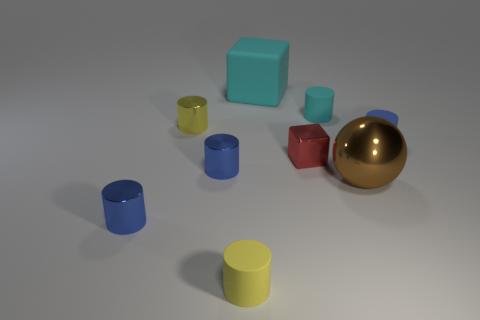Subtract all blue cylinders. How many were subtracted if there are1blue cylinders left? 2 Subtract all small yellow cylinders. How many cylinders are left? 4 Subtract all cyan cylinders. How many cylinders are left? 5 Subtract 3 cylinders. How many cylinders are left? 3 Subtract all purple balls. How many blue cylinders are left? 3 Add 9 small red metallic blocks. How many small red metallic blocks are left? 10 Add 4 tiny blue objects. How many tiny blue objects exist? 7 Subtract 0 purple spheres. How many objects are left? 9 Subtract all balls. How many objects are left? 8 Subtract all gray cylinders. Subtract all brown balls. How many cylinders are left? 6 